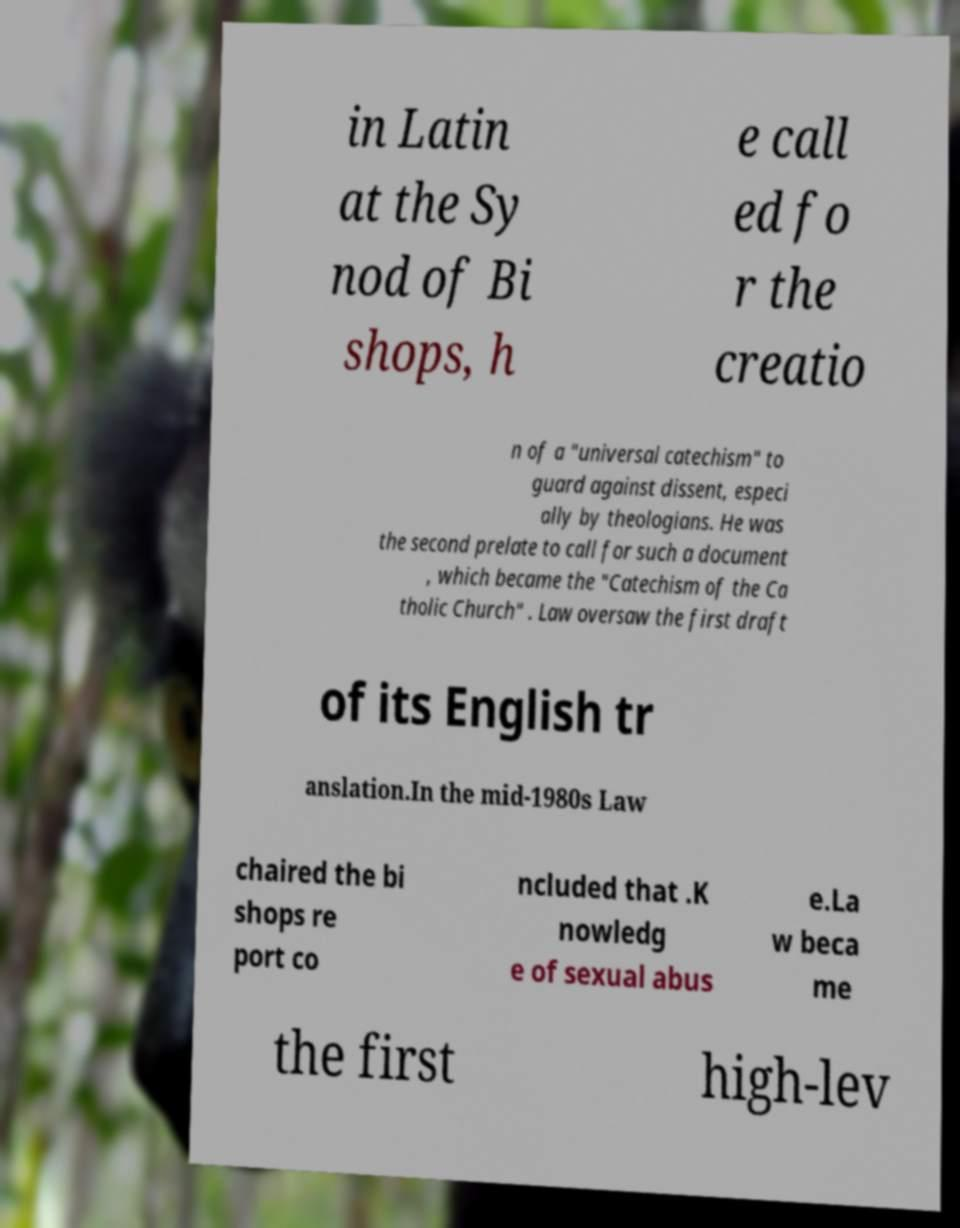Can you read and provide the text displayed in the image?This photo seems to have some interesting text. Can you extract and type it out for me? in Latin at the Sy nod of Bi shops, h e call ed fo r the creatio n of a "universal catechism" to guard against dissent, especi ally by theologians. He was the second prelate to call for such a document , which became the "Catechism of the Ca tholic Church" . Law oversaw the first draft of its English tr anslation.In the mid-1980s Law chaired the bi shops re port co ncluded that .K nowledg e of sexual abus e.La w beca me the first high-lev 